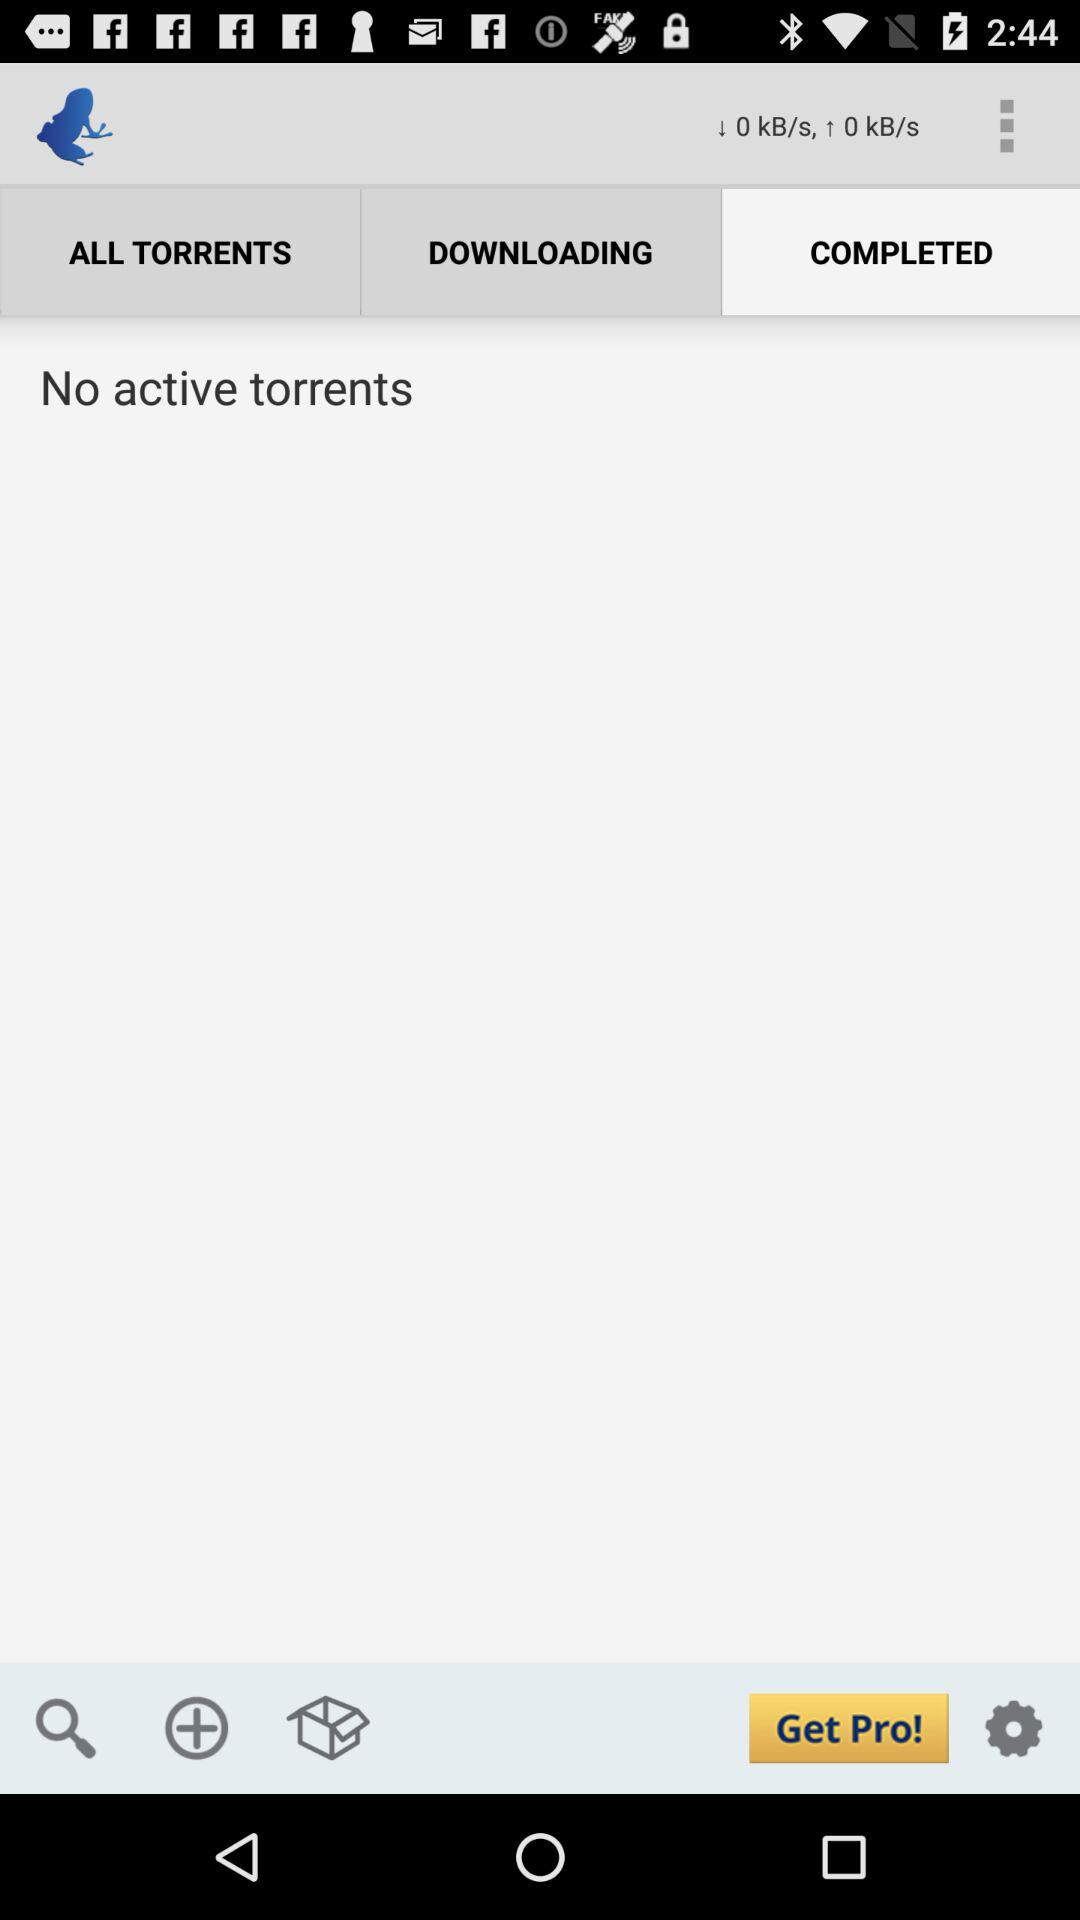What is the downloading speed? The downloading speed is 0 kB/s. 